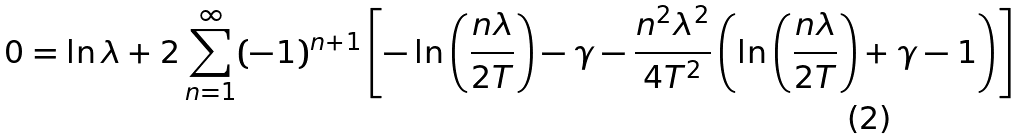<formula> <loc_0><loc_0><loc_500><loc_500>0 = \ln \lambda + 2 \sum _ { n = 1 } ^ { \infty } ( - 1 ) ^ { n + 1 } \left [ - \ln \left ( \frac { n \lambda } { 2 T } \right ) - \gamma - \frac { n ^ { 2 } \lambda ^ { 2 } } { 4 T ^ { 2 } } \left ( \ln \left ( \frac { n \lambda } { 2 T } \right ) + \gamma - 1 \right ) \right ]</formula> 